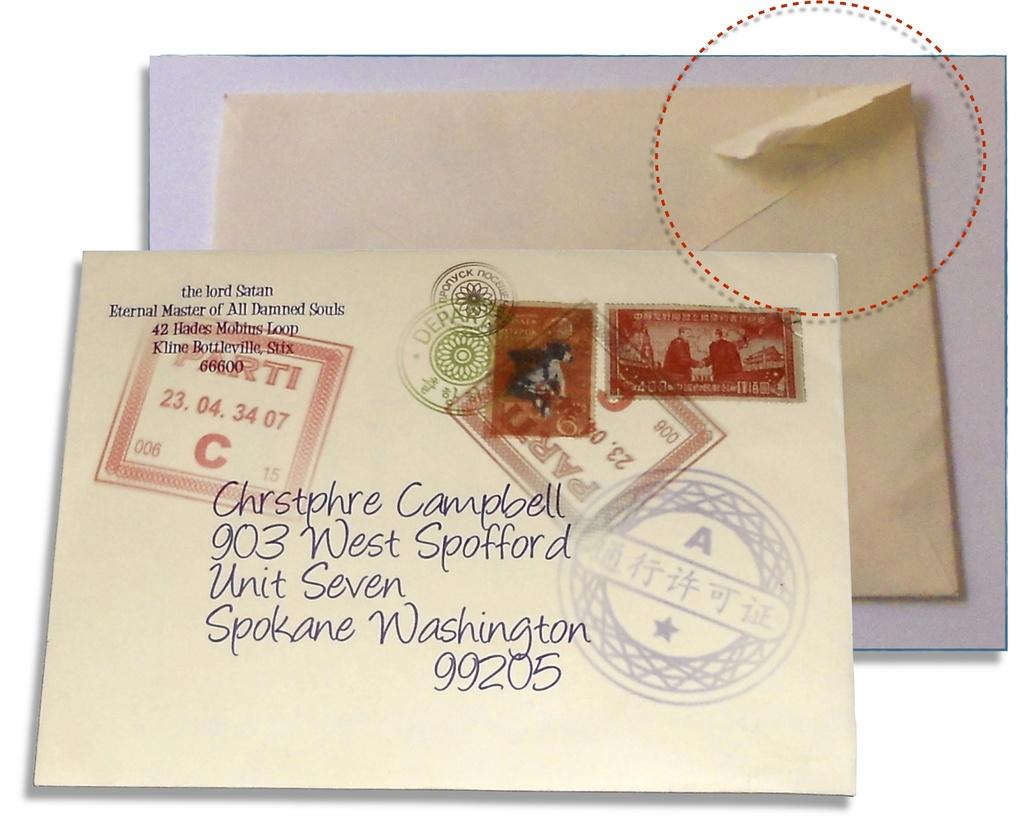<image>
Provide a brief description of the given image. A letter is addressed to Chrstphre Cambell in Spokane, Washington. 